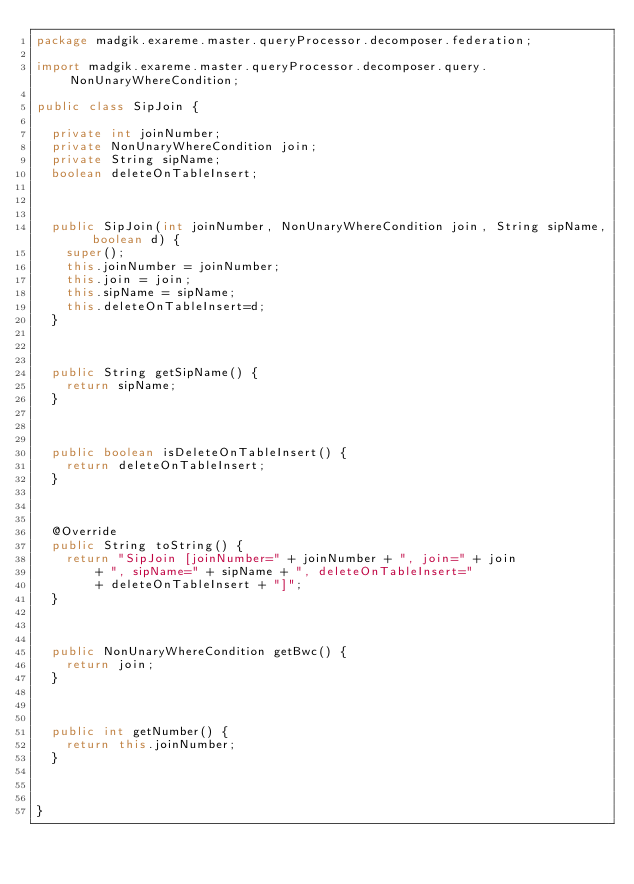Convert code to text. <code><loc_0><loc_0><loc_500><loc_500><_Java_>package madgik.exareme.master.queryProcessor.decomposer.federation;

import madgik.exareme.master.queryProcessor.decomposer.query.NonUnaryWhereCondition;

public class SipJoin {
	
	private int joinNumber;
	private NonUnaryWhereCondition join;
	private String sipName;
	boolean deleteOnTableInsert;
	
	
	
	public SipJoin(int joinNumber, NonUnaryWhereCondition join, String sipName, boolean d) {
		super();
		this.joinNumber = joinNumber;
		this.join = join;
		this.sipName = sipName;
		this.deleteOnTableInsert=d;
	}



	public String getSipName() {
		return sipName;
	}



	public boolean isDeleteOnTableInsert() {
		return deleteOnTableInsert;
	}



	@Override
	public String toString() {
		return "SipJoin [joinNumber=" + joinNumber + ", join=" + join
				+ ", sipName=" + sipName + ", deleteOnTableInsert="
				+ deleteOnTableInsert + "]";
	}



	public NonUnaryWhereCondition getBwc() {
		return join;
	}



	public int getNumber() {
		return this.joinNumber;
	}
	
	

}
</code> 